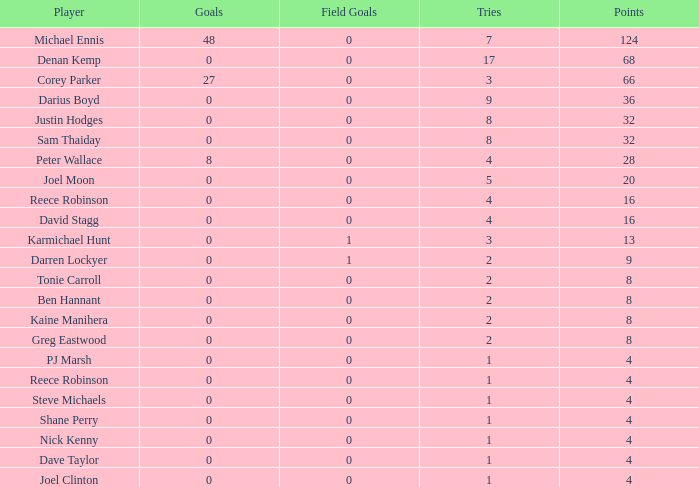How many points did the player with 2 tries and more than 0 field goals have? 9.0. 